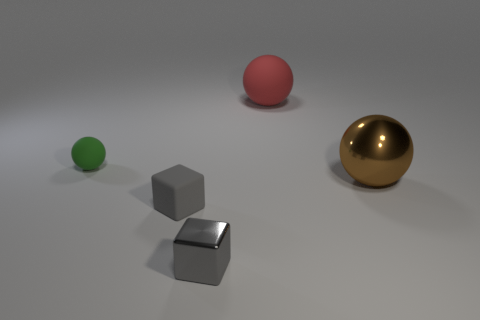What shape is the tiny gray thing on the left side of the metal object that is on the left side of the large thing that is to the left of the metal ball?
Offer a very short reply. Cube. How big is the red sphere?
Your answer should be very brief. Large. What is the color of the other object that is made of the same material as the large brown thing?
Your response must be concise. Gray. What number of other tiny balls have the same material as the small green sphere?
Keep it short and to the point. 0. There is a matte cube; does it have the same color as the metallic cube that is in front of the green sphere?
Keep it short and to the point. Yes. There is a large sphere that is behind the metallic object behind the gray rubber block; what color is it?
Ensure brevity in your answer.  Red. What color is the other object that is the same size as the red rubber object?
Ensure brevity in your answer.  Brown. Are there any other objects of the same shape as the small green rubber object?
Offer a terse response. Yes. The big rubber thing has what shape?
Give a very brief answer. Sphere. Is the number of small gray things that are in front of the small gray matte cube greater than the number of tiny matte balls left of the tiny rubber ball?
Offer a very short reply. Yes. 